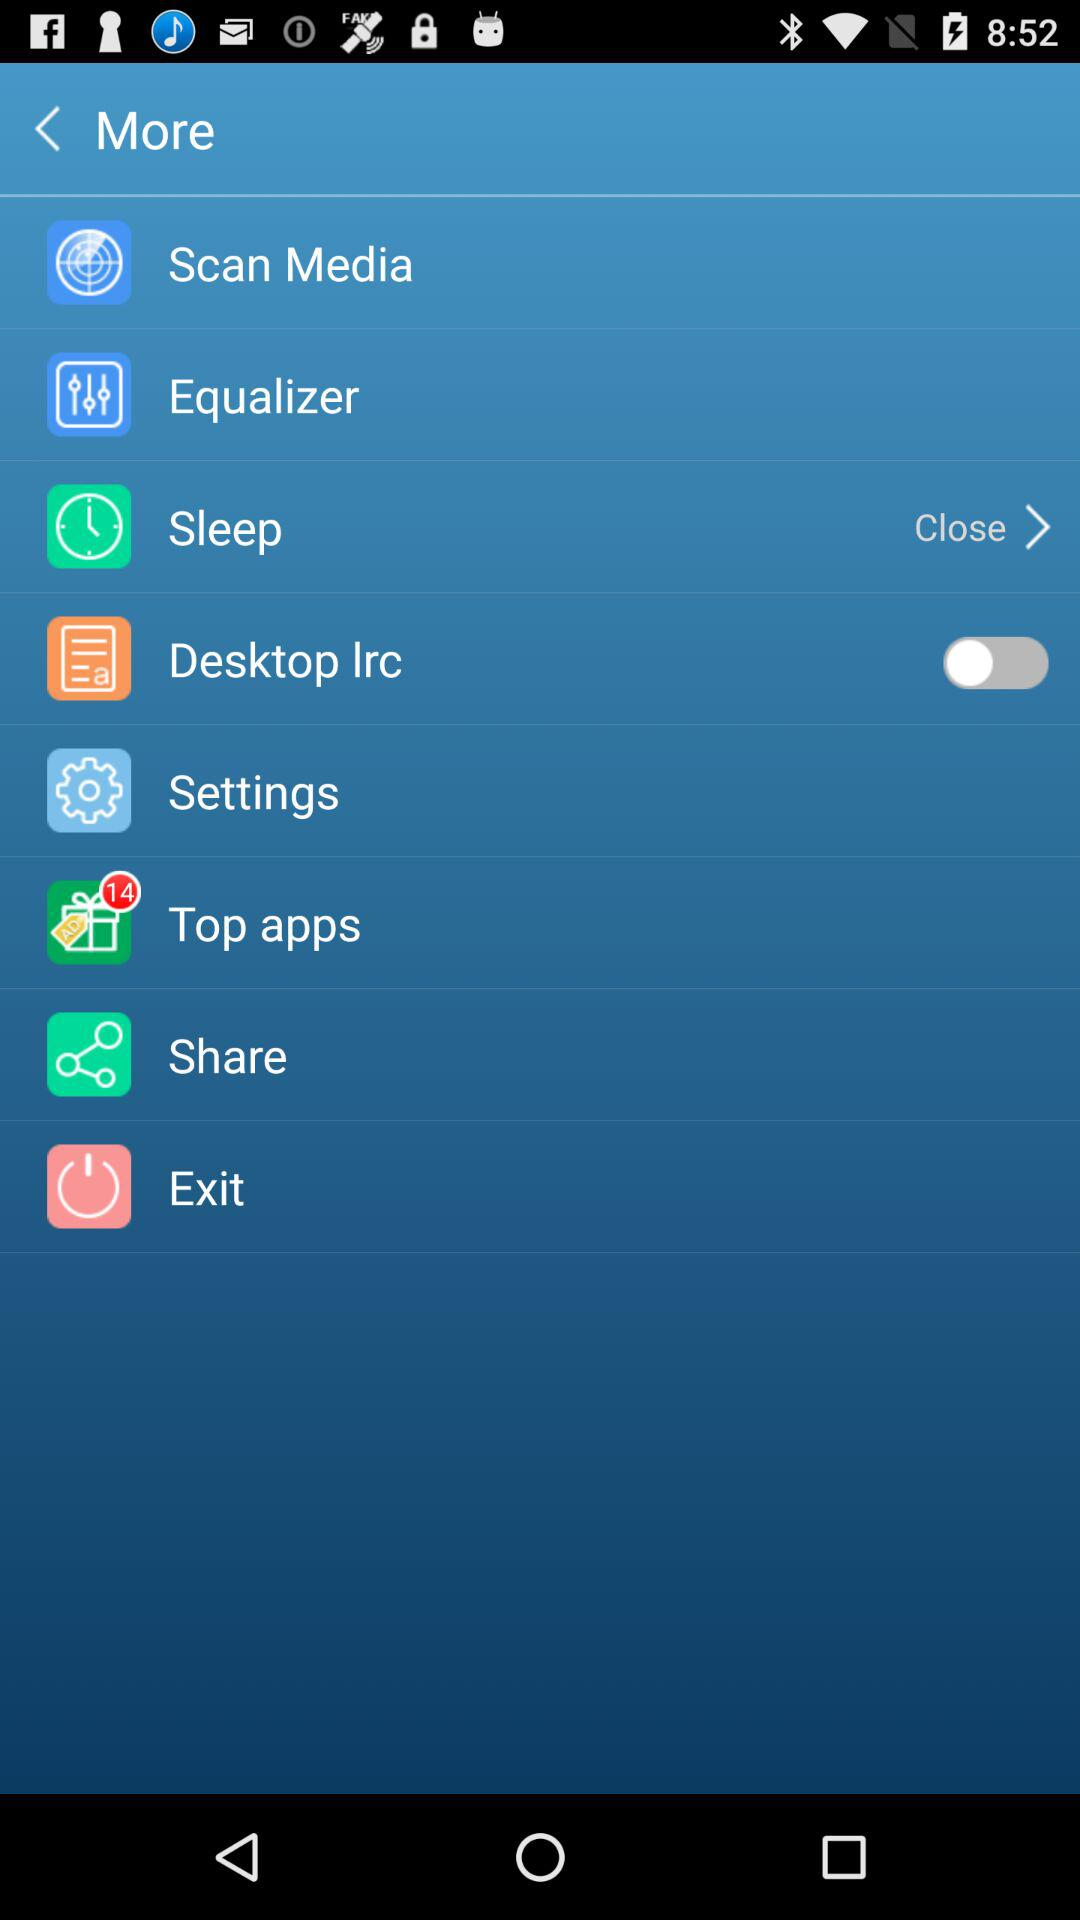How many new notifications are in the "Top apps"? There are 14 new notifications. 